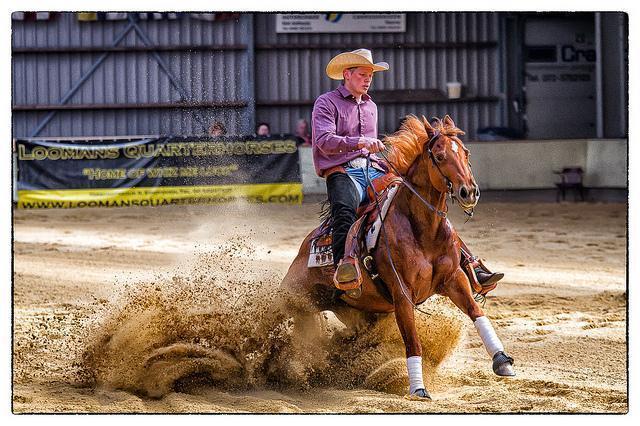How many people are in the photo?
Give a very brief answer. 1. 